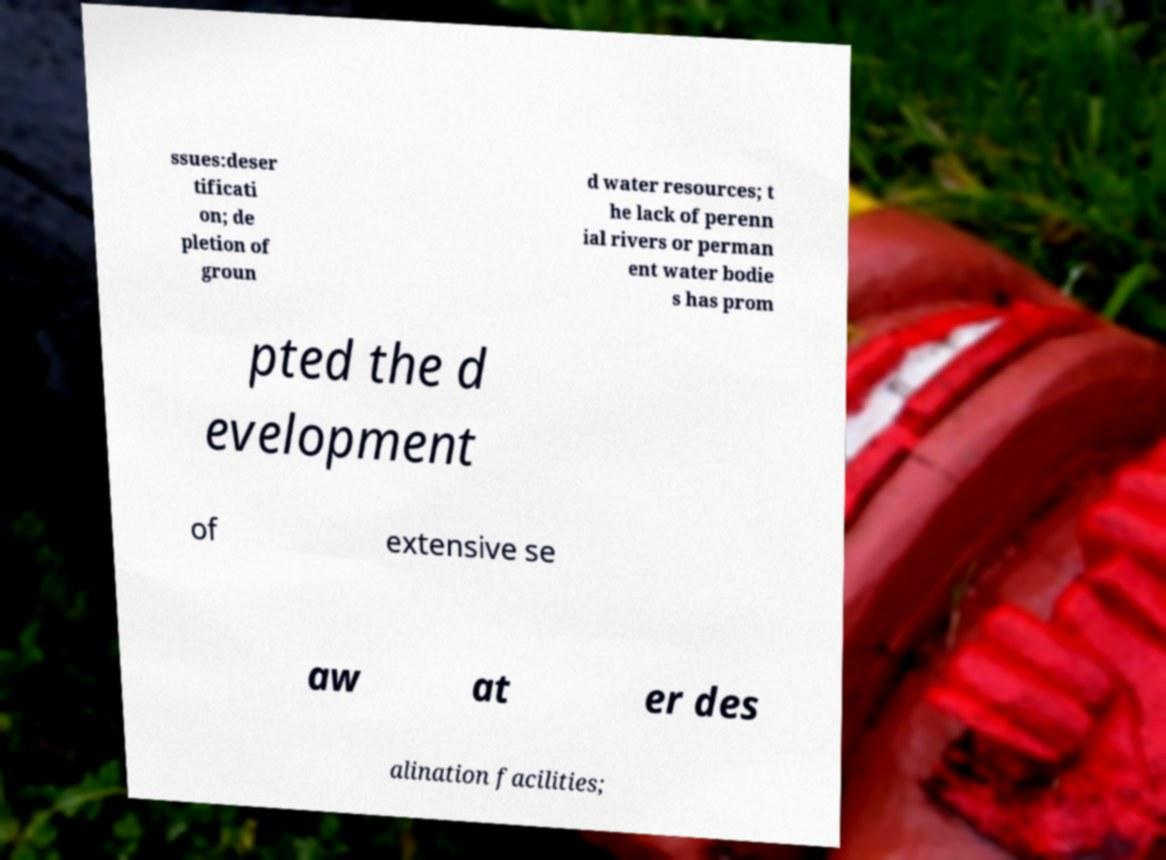Could you assist in decoding the text presented in this image and type it out clearly? ssues:deser tificati on; de pletion of groun d water resources; t he lack of perenn ial rivers or perman ent water bodie s has prom pted the d evelopment of extensive se aw at er des alination facilities; 